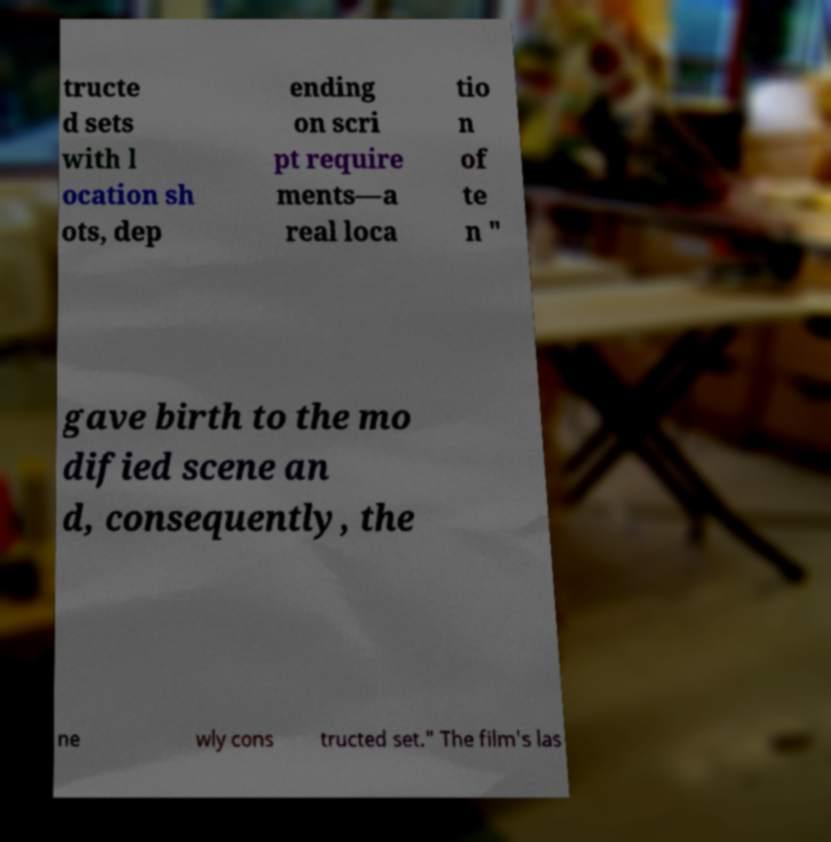What messages or text are displayed in this image? I need them in a readable, typed format. tructe d sets with l ocation sh ots, dep ending on scri pt require ments—a real loca tio n of te n " gave birth to the mo dified scene an d, consequently, the ne wly cons tructed set." The film's las 